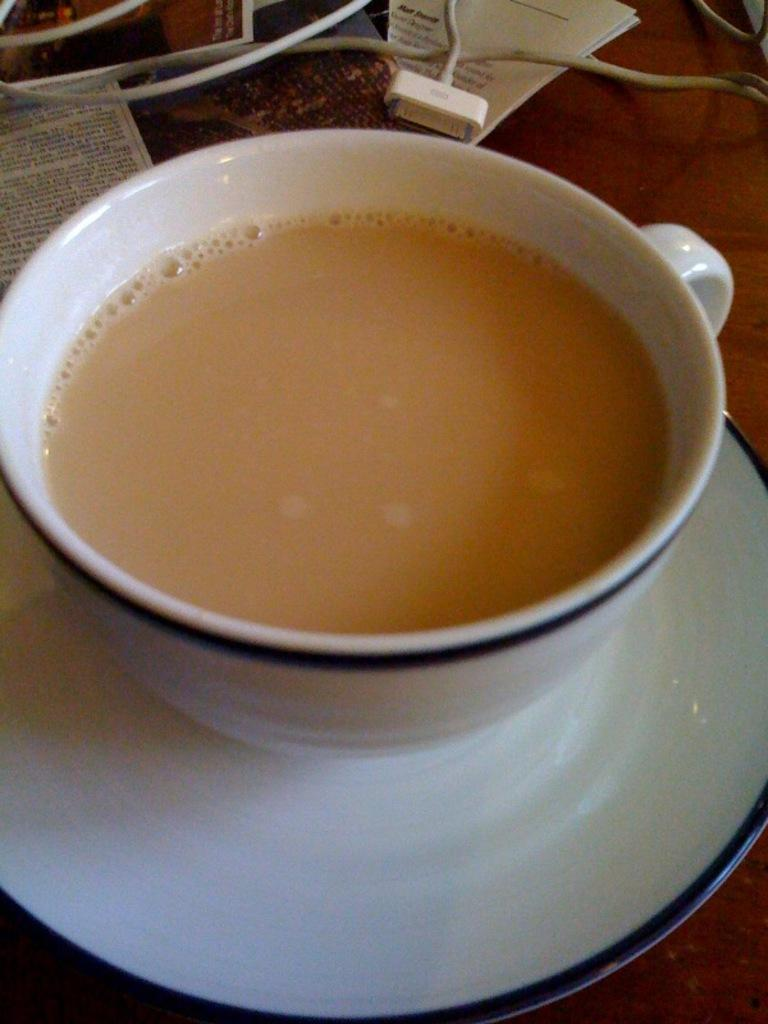What is on the saucer in the image? There is a cup of tea on a saucer in the image. Where is the cup of tea placed? The cup of tea is placed on a table. What else can be seen on the table? There are cables and papers on the table. What type of bit is used for the faucet in the image? There is no faucet present in the image, so it is not possible to determine what type of bit might be used. 